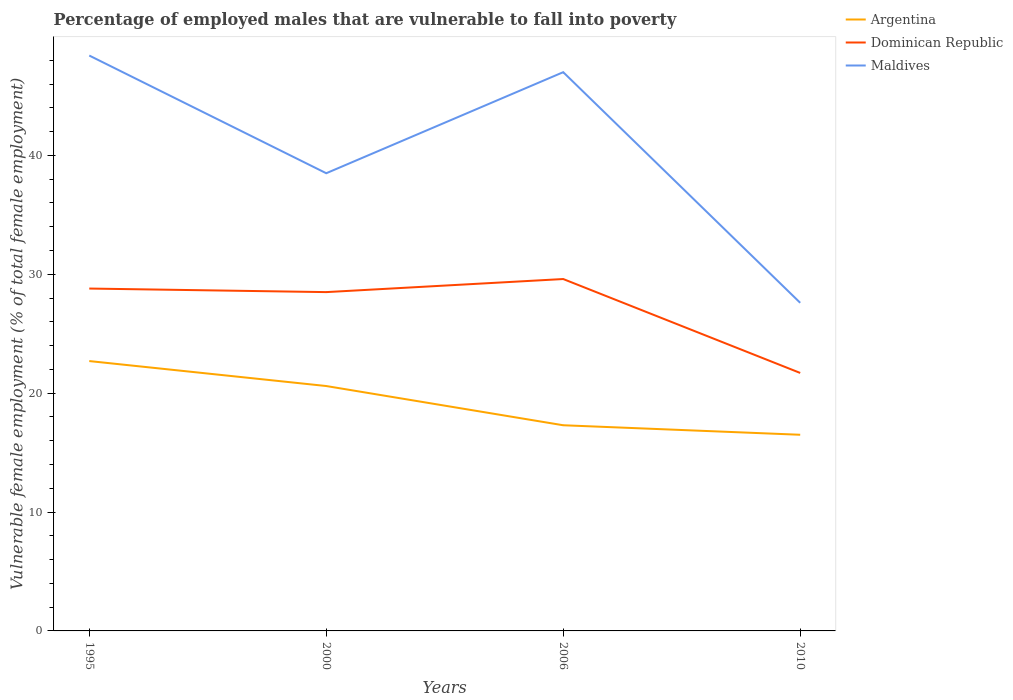Does the line corresponding to Maldives intersect with the line corresponding to Dominican Republic?
Your answer should be compact. No. Is the number of lines equal to the number of legend labels?
Your answer should be compact. Yes. In which year was the percentage of employed males who are vulnerable to fall into poverty in Dominican Republic maximum?
Your answer should be compact. 2010. What is the total percentage of employed males who are vulnerable to fall into poverty in Maldives in the graph?
Offer a very short reply. 10.9. What is the difference between the highest and the second highest percentage of employed males who are vulnerable to fall into poverty in Maldives?
Your answer should be compact. 20.8. How many years are there in the graph?
Provide a succinct answer. 4. How many legend labels are there?
Your response must be concise. 3. How are the legend labels stacked?
Offer a very short reply. Vertical. What is the title of the graph?
Your response must be concise. Percentage of employed males that are vulnerable to fall into poverty. What is the label or title of the X-axis?
Offer a very short reply. Years. What is the label or title of the Y-axis?
Make the answer very short. Vulnerable female employment (% of total female employment). What is the Vulnerable female employment (% of total female employment) of Argentina in 1995?
Keep it short and to the point. 22.7. What is the Vulnerable female employment (% of total female employment) in Dominican Republic in 1995?
Your answer should be compact. 28.8. What is the Vulnerable female employment (% of total female employment) of Maldives in 1995?
Provide a short and direct response. 48.4. What is the Vulnerable female employment (% of total female employment) in Argentina in 2000?
Ensure brevity in your answer.  20.6. What is the Vulnerable female employment (% of total female employment) in Maldives in 2000?
Offer a terse response. 38.5. What is the Vulnerable female employment (% of total female employment) in Argentina in 2006?
Provide a succinct answer. 17.3. What is the Vulnerable female employment (% of total female employment) of Dominican Republic in 2006?
Your answer should be very brief. 29.6. What is the Vulnerable female employment (% of total female employment) of Dominican Republic in 2010?
Your answer should be very brief. 21.7. What is the Vulnerable female employment (% of total female employment) of Maldives in 2010?
Offer a terse response. 27.6. Across all years, what is the maximum Vulnerable female employment (% of total female employment) in Argentina?
Provide a short and direct response. 22.7. Across all years, what is the maximum Vulnerable female employment (% of total female employment) in Dominican Republic?
Your response must be concise. 29.6. Across all years, what is the maximum Vulnerable female employment (% of total female employment) in Maldives?
Provide a short and direct response. 48.4. Across all years, what is the minimum Vulnerable female employment (% of total female employment) of Dominican Republic?
Ensure brevity in your answer.  21.7. Across all years, what is the minimum Vulnerable female employment (% of total female employment) of Maldives?
Your answer should be very brief. 27.6. What is the total Vulnerable female employment (% of total female employment) in Argentina in the graph?
Offer a terse response. 77.1. What is the total Vulnerable female employment (% of total female employment) of Dominican Republic in the graph?
Ensure brevity in your answer.  108.6. What is the total Vulnerable female employment (% of total female employment) in Maldives in the graph?
Make the answer very short. 161.5. What is the difference between the Vulnerable female employment (% of total female employment) in Argentina in 1995 and that in 2000?
Your answer should be compact. 2.1. What is the difference between the Vulnerable female employment (% of total female employment) of Argentina in 1995 and that in 2006?
Provide a short and direct response. 5.4. What is the difference between the Vulnerable female employment (% of total female employment) of Argentina in 1995 and that in 2010?
Your answer should be very brief. 6.2. What is the difference between the Vulnerable female employment (% of total female employment) in Maldives in 1995 and that in 2010?
Give a very brief answer. 20.8. What is the difference between the Vulnerable female employment (% of total female employment) of Argentina in 2000 and that in 2006?
Your answer should be compact. 3.3. What is the difference between the Vulnerable female employment (% of total female employment) in Dominican Republic in 2000 and that in 2006?
Your answer should be compact. -1.1. What is the difference between the Vulnerable female employment (% of total female employment) in Argentina in 2000 and that in 2010?
Your answer should be very brief. 4.1. What is the difference between the Vulnerable female employment (% of total female employment) in Dominican Republic in 2000 and that in 2010?
Make the answer very short. 6.8. What is the difference between the Vulnerable female employment (% of total female employment) of Argentina in 2006 and that in 2010?
Your response must be concise. 0.8. What is the difference between the Vulnerable female employment (% of total female employment) in Maldives in 2006 and that in 2010?
Provide a succinct answer. 19.4. What is the difference between the Vulnerable female employment (% of total female employment) in Argentina in 1995 and the Vulnerable female employment (% of total female employment) in Maldives in 2000?
Offer a terse response. -15.8. What is the difference between the Vulnerable female employment (% of total female employment) of Argentina in 1995 and the Vulnerable female employment (% of total female employment) of Maldives in 2006?
Your answer should be compact. -24.3. What is the difference between the Vulnerable female employment (% of total female employment) of Dominican Republic in 1995 and the Vulnerable female employment (% of total female employment) of Maldives in 2006?
Offer a terse response. -18.2. What is the difference between the Vulnerable female employment (% of total female employment) of Argentina in 1995 and the Vulnerable female employment (% of total female employment) of Dominican Republic in 2010?
Your answer should be compact. 1. What is the difference between the Vulnerable female employment (% of total female employment) in Dominican Republic in 1995 and the Vulnerable female employment (% of total female employment) in Maldives in 2010?
Your answer should be very brief. 1.2. What is the difference between the Vulnerable female employment (% of total female employment) of Argentina in 2000 and the Vulnerable female employment (% of total female employment) of Maldives in 2006?
Offer a terse response. -26.4. What is the difference between the Vulnerable female employment (% of total female employment) of Dominican Republic in 2000 and the Vulnerable female employment (% of total female employment) of Maldives in 2006?
Make the answer very short. -18.5. What is the difference between the Vulnerable female employment (% of total female employment) of Argentina in 2000 and the Vulnerable female employment (% of total female employment) of Dominican Republic in 2010?
Your answer should be compact. -1.1. What is the difference between the Vulnerable female employment (% of total female employment) of Argentina in 2000 and the Vulnerable female employment (% of total female employment) of Maldives in 2010?
Your answer should be very brief. -7. What is the difference between the Vulnerable female employment (% of total female employment) of Dominican Republic in 2000 and the Vulnerable female employment (% of total female employment) of Maldives in 2010?
Make the answer very short. 0.9. What is the difference between the Vulnerable female employment (% of total female employment) of Argentina in 2006 and the Vulnerable female employment (% of total female employment) of Maldives in 2010?
Your response must be concise. -10.3. What is the difference between the Vulnerable female employment (% of total female employment) in Dominican Republic in 2006 and the Vulnerable female employment (% of total female employment) in Maldives in 2010?
Give a very brief answer. 2. What is the average Vulnerable female employment (% of total female employment) in Argentina per year?
Your answer should be very brief. 19.27. What is the average Vulnerable female employment (% of total female employment) in Dominican Republic per year?
Your answer should be very brief. 27.15. What is the average Vulnerable female employment (% of total female employment) in Maldives per year?
Keep it short and to the point. 40.38. In the year 1995, what is the difference between the Vulnerable female employment (% of total female employment) in Argentina and Vulnerable female employment (% of total female employment) in Maldives?
Keep it short and to the point. -25.7. In the year 1995, what is the difference between the Vulnerable female employment (% of total female employment) of Dominican Republic and Vulnerable female employment (% of total female employment) of Maldives?
Your answer should be compact. -19.6. In the year 2000, what is the difference between the Vulnerable female employment (% of total female employment) in Argentina and Vulnerable female employment (% of total female employment) in Maldives?
Make the answer very short. -17.9. In the year 2006, what is the difference between the Vulnerable female employment (% of total female employment) of Argentina and Vulnerable female employment (% of total female employment) of Dominican Republic?
Your answer should be very brief. -12.3. In the year 2006, what is the difference between the Vulnerable female employment (% of total female employment) in Argentina and Vulnerable female employment (% of total female employment) in Maldives?
Keep it short and to the point. -29.7. In the year 2006, what is the difference between the Vulnerable female employment (% of total female employment) of Dominican Republic and Vulnerable female employment (% of total female employment) of Maldives?
Provide a short and direct response. -17.4. In the year 2010, what is the difference between the Vulnerable female employment (% of total female employment) of Argentina and Vulnerable female employment (% of total female employment) of Dominican Republic?
Offer a terse response. -5.2. In the year 2010, what is the difference between the Vulnerable female employment (% of total female employment) of Argentina and Vulnerable female employment (% of total female employment) of Maldives?
Provide a short and direct response. -11.1. What is the ratio of the Vulnerable female employment (% of total female employment) in Argentina in 1995 to that in 2000?
Your response must be concise. 1.1. What is the ratio of the Vulnerable female employment (% of total female employment) of Dominican Republic in 1995 to that in 2000?
Offer a terse response. 1.01. What is the ratio of the Vulnerable female employment (% of total female employment) in Maldives in 1995 to that in 2000?
Provide a succinct answer. 1.26. What is the ratio of the Vulnerable female employment (% of total female employment) in Argentina in 1995 to that in 2006?
Provide a succinct answer. 1.31. What is the ratio of the Vulnerable female employment (% of total female employment) of Maldives in 1995 to that in 2006?
Provide a succinct answer. 1.03. What is the ratio of the Vulnerable female employment (% of total female employment) in Argentina in 1995 to that in 2010?
Your response must be concise. 1.38. What is the ratio of the Vulnerable female employment (% of total female employment) of Dominican Republic in 1995 to that in 2010?
Your answer should be compact. 1.33. What is the ratio of the Vulnerable female employment (% of total female employment) in Maldives in 1995 to that in 2010?
Your answer should be compact. 1.75. What is the ratio of the Vulnerable female employment (% of total female employment) of Argentina in 2000 to that in 2006?
Provide a succinct answer. 1.19. What is the ratio of the Vulnerable female employment (% of total female employment) of Dominican Republic in 2000 to that in 2006?
Keep it short and to the point. 0.96. What is the ratio of the Vulnerable female employment (% of total female employment) in Maldives in 2000 to that in 2006?
Your answer should be very brief. 0.82. What is the ratio of the Vulnerable female employment (% of total female employment) in Argentina in 2000 to that in 2010?
Make the answer very short. 1.25. What is the ratio of the Vulnerable female employment (% of total female employment) in Dominican Republic in 2000 to that in 2010?
Ensure brevity in your answer.  1.31. What is the ratio of the Vulnerable female employment (% of total female employment) of Maldives in 2000 to that in 2010?
Your response must be concise. 1.39. What is the ratio of the Vulnerable female employment (% of total female employment) of Argentina in 2006 to that in 2010?
Offer a very short reply. 1.05. What is the ratio of the Vulnerable female employment (% of total female employment) in Dominican Republic in 2006 to that in 2010?
Offer a terse response. 1.36. What is the ratio of the Vulnerable female employment (% of total female employment) in Maldives in 2006 to that in 2010?
Ensure brevity in your answer.  1.7. What is the difference between the highest and the second highest Vulnerable female employment (% of total female employment) of Argentina?
Provide a succinct answer. 2.1. What is the difference between the highest and the second highest Vulnerable female employment (% of total female employment) of Dominican Republic?
Your answer should be very brief. 0.8. What is the difference between the highest and the second highest Vulnerable female employment (% of total female employment) of Maldives?
Provide a short and direct response. 1.4. What is the difference between the highest and the lowest Vulnerable female employment (% of total female employment) in Argentina?
Your answer should be very brief. 6.2. What is the difference between the highest and the lowest Vulnerable female employment (% of total female employment) of Maldives?
Offer a terse response. 20.8. 